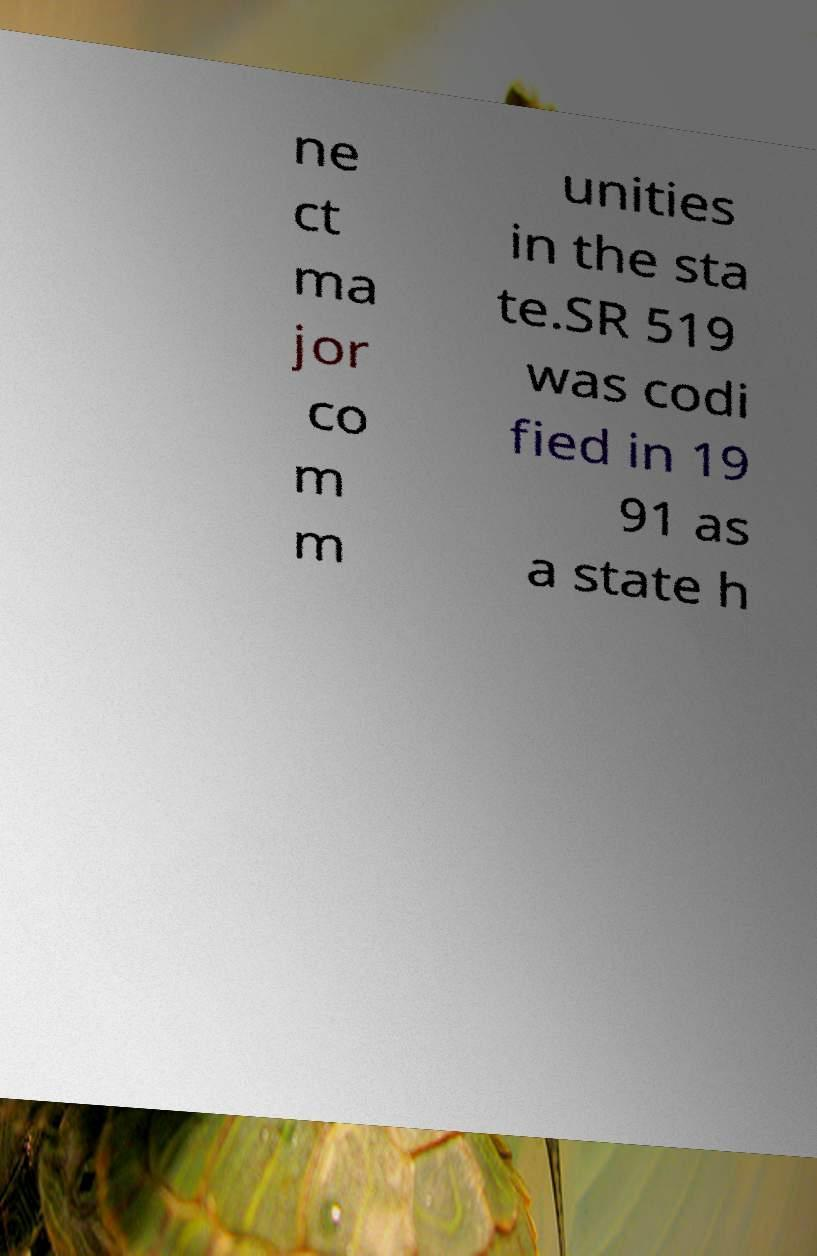What messages or text are displayed in this image? I need them in a readable, typed format. ne ct ma jor co m m unities in the sta te.SR 519 was codi fied in 19 91 as a state h 